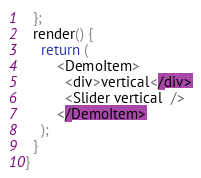<code> <loc_0><loc_0><loc_500><loc_500><_JavaScript_>  };
  render() {
    return (
        <DemoItem>
          <div>vertical</div>
          <Slider vertical  />
        </DemoItem>
    );
  }
}
</code> 